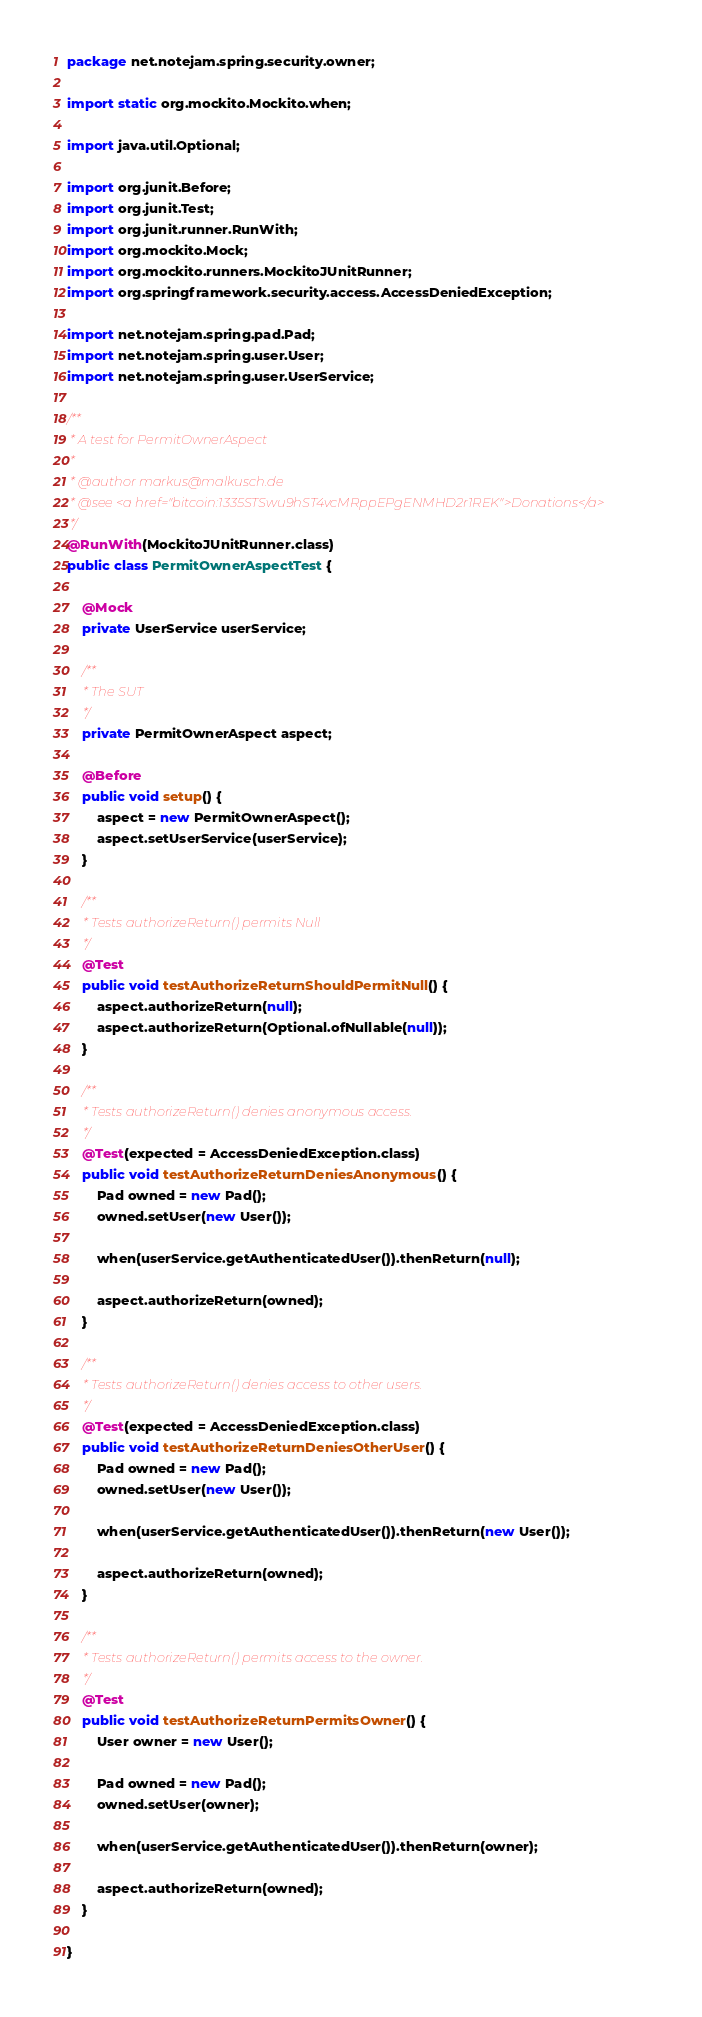<code> <loc_0><loc_0><loc_500><loc_500><_Java_>package net.notejam.spring.security.owner;

import static org.mockito.Mockito.when;

import java.util.Optional;

import org.junit.Before;
import org.junit.Test;
import org.junit.runner.RunWith;
import org.mockito.Mock;
import org.mockito.runners.MockitoJUnitRunner;
import org.springframework.security.access.AccessDeniedException;

import net.notejam.spring.pad.Pad;
import net.notejam.spring.user.User;
import net.notejam.spring.user.UserService;

/**
 * A test for PermitOwnerAspect
 *
 * @author markus@malkusch.de
 * @see <a href="bitcoin:1335STSwu9hST4vcMRppEPgENMHD2r1REK">Donations</a>
 */
@RunWith(MockitoJUnitRunner.class)
public class PermitOwnerAspectTest {

    @Mock
    private UserService userService;

    /**
     * The SUT
     */
    private PermitOwnerAspect aspect;

    @Before
    public void setup() {
        aspect = new PermitOwnerAspect();
        aspect.setUserService(userService);
    }

    /**
     * Tests authorizeReturn() permits Null
     */
    @Test
    public void testAuthorizeReturnShouldPermitNull() {
        aspect.authorizeReturn(null);
        aspect.authorizeReturn(Optional.ofNullable(null));
    }

    /**
     * Tests authorizeReturn() denies anonymous access.
     */
    @Test(expected = AccessDeniedException.class)
    public void testAuthorizeReturnDeniesAnonymous() {
        Pad owned = new Pad();
        owned.setUser(new User());

        when(userService.getAuthenticatedUser()).thenReturn(null);

        aspect.authorizeReturn(owned);
    }

    /**
     * Tests authorizeReturn() denies access to other users.
     */
    @Test(expected = AccessDeniedException.class)
    public void testAuthorizeReturnDeniesOtherUser() {
        Pad owned = new Pad();
        owned.setUser(new User());

        when(userService.getAuthenticatedUser()).thenReturn(new User());

        aspect.authorizeReturn(owned);
    }

    /**
     * Tests authorizeReturn() permits access to the owner.
     */
    @Test
    public void testAuthorizeReturnPermitsOwner() {
        User owner = new User();

        Pad owned = new Pad();
        owned.setUser(owner);

        when(userService.getAuthenticatedUser()).thenReturn(owner);

        aspect.authorizeReturn(owned);
    }

}
</code> 